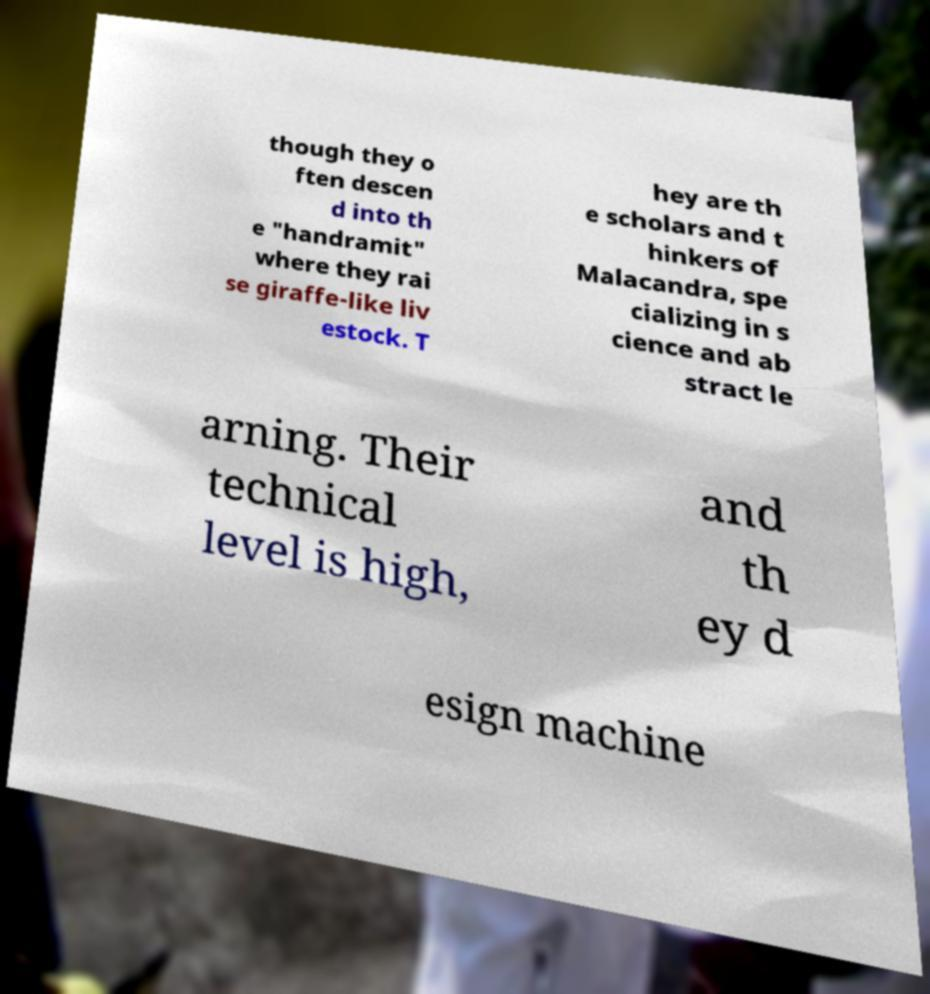Please read and relay the text visible in this image. What does it say? though they o ften descen d into th e "handramit" where they rai se giraffe-like liv estock. T hey are th e scholars and t hinkers of Malacandra, spe cializing in s cience and ab stract le arning. Their technical level is high, and th ey d esign machine 